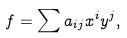<formula> <loc_0><loc_0><loc_500><loc_500>f = \sum a _ { i j } x ^ { i } y ^ { j } ,</formula> 